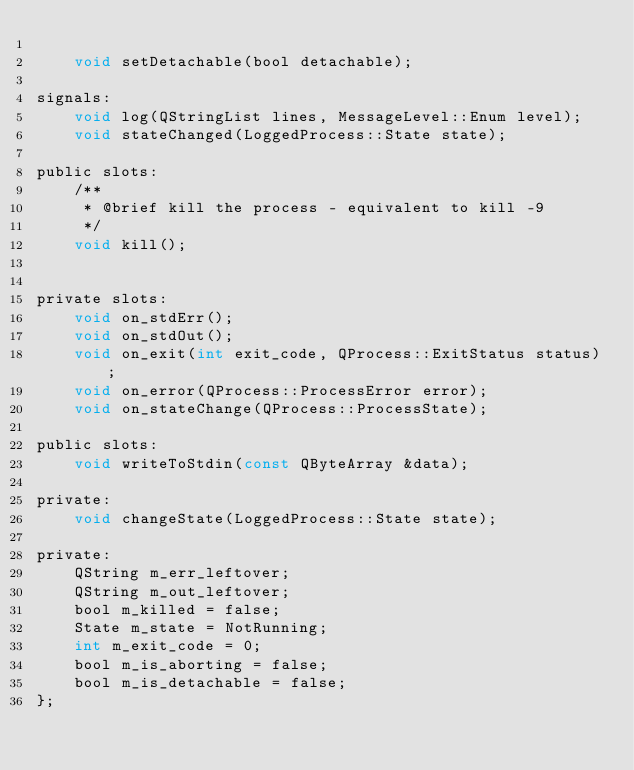Convert code to text. <code><loc_0><loc_0><loc_500><loc_500><_C_>
    void setDetachable(bool detachable);

signals:
    void log(QStringList lines, MessageLevel::Enum level);
    void stateChanged(LoggedProcess::State state);

public slots:
    /**
     * @brief kill the process - equivalent to kill -9
     */
    void kill();


private slots:
    void on_stdErr();
    void on_stdOut();
    void on_exit(int exit_code, QProcess::ExitStatus status);
    void on_error(QProcess::ProcessError error);
    void on_stateChange(QProcess::ProcessState);

public slots:
    void writeToStdin(const QByteArray &data);

private:
    void changeState(LoggedProcess::State state);

private:
    QString m_err_leftover;
    QString m_out_leftover;
    bool m_killed = false;
    State m_state = NotRunning;
    int m_exit_code = 0;
    bool m_is_aborting = false;
    bool m_is_detachable = false;
};
</code> 